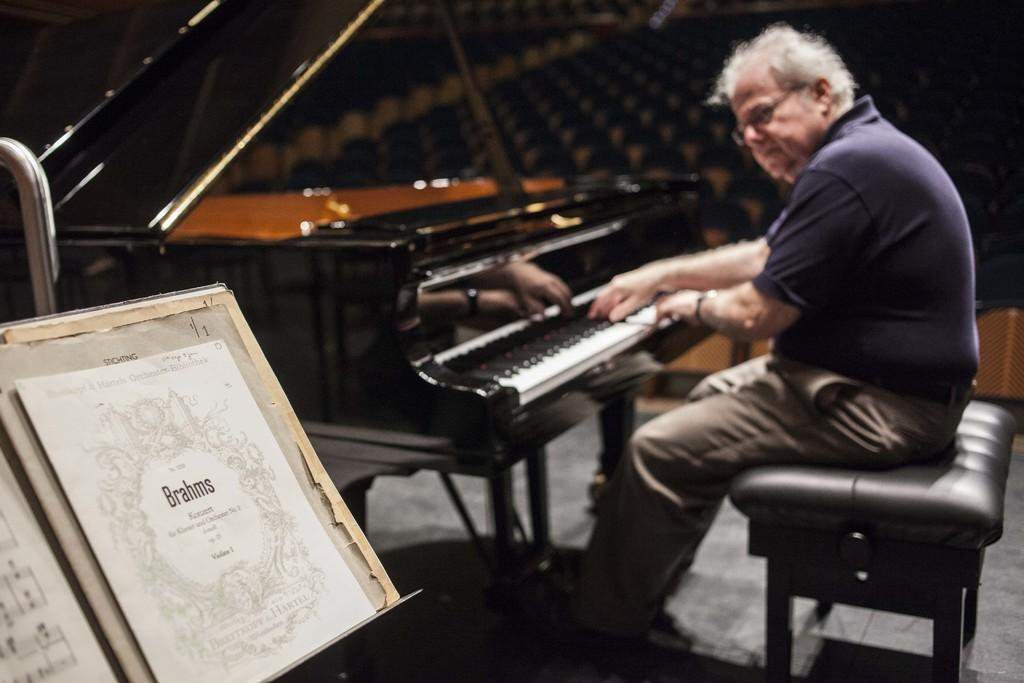Who is the main subject in the image? There is an old man in the image. What is the old man doing in the image? The old man is sitting and playing a piano. What can be seen near the piano in the image? There is a stand with musical notes in the image. What type of bait is the old man using to catch fish in the image? There is no indication of fishing or bait in the image; the old man is playing a piano. 